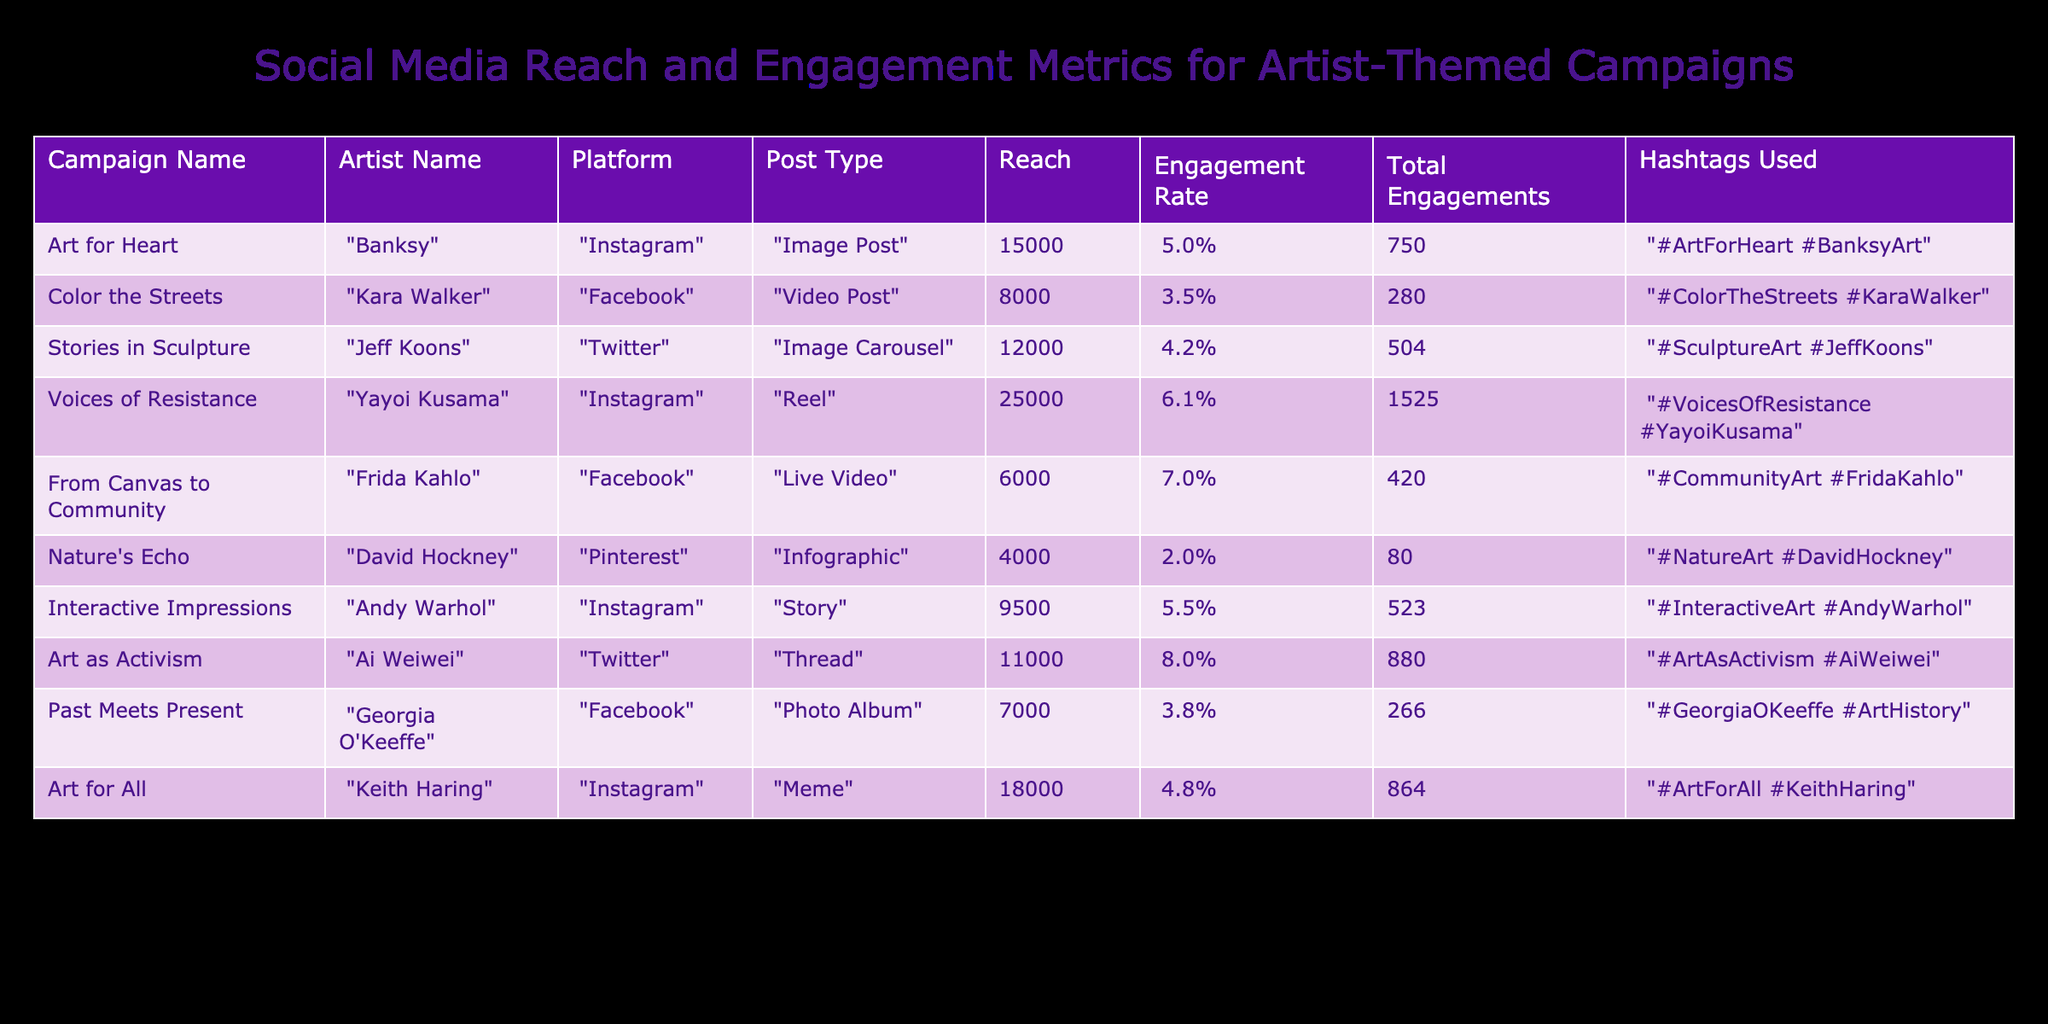What is the total reach for the campaign "Voices of Resistance"? The table shows that the reach for "Voices of Resistance" is listed in its respective row. By directly referring to the 'Reach' column for this campaign, we can see that it is 25000.
Answer: 25000 Which artist's campaign had the highest engagement rate? To find the highest engagement rate, we can look at the 'Engagement Rate' column. Comparing the values, we see that "Art as Activism" by Ai Weiwei has the highest engagement rate of 8.0%.
Answer: Ai Weiwei What is the average total engagements across all campaigns? We first need to sum the total engagements of all campaigns. The values are 750, 280, 504, 1525, 420, 80, 523, 880, 266, and 864. Adding these gives a total of 4878. There are 10 campaigns, so the average is 4878 divided by 10, which equals 487.8.
Answer: 487.8 Did all campaigns use hashtags? We can check all the rows in the 'Hashtags Used' column to see if there are any missing entries. Each campaign listed has associated hashtags, meaning all campaigns used hashtags.
Answer: Yes How much more reach did "Art for Heart" have compared to "Nature's Echo"? To find the difference in reach, we look at "Art for Heart," which has a reach of 15000, and "Nature's Echo," which has a reach of 4000. Subtracting these gives 15000 - 4000 = 11000 as the additional reach of "Art for Heart."
Answer: 11000 Which platform had the highest total engagement from all campaigns combined? To determine the platform with the highest total engagements, we sum the total engagements for each platform: Instagram (750 + 1525 + 523 + 864 = 2862), Facebook (280 + 420 + 266 = 966), Twitter (504 + 880 = 1384), and Pinterest (80). The highest is Instagram with a total of 2862 engagements.
Answer: Instagram What percentage of total engagements came from "Interactive Impressions"? First, find the total engagements from "Interactive Impressions," which is 523. Then, compare it with the total engagements of all campaigns, which is 4878. The percentage is calculated as (523 / 4878) * 100 = approximately 10.7%.
Answer: 10.7% Is it true that all campaigns conducted through Facebook had lower engagement rates than those conducted on Instagram? We first check the 'Engagement Rate' for the Facebook campaigns: "Color the Streets" (3.5%), "From Canvas to Community" (7.0%), and "Past Meets Present" (3.8%). Comparing these with Instagram campaigns: "Art for Heart" (5.0%), "Voices of Resistance" (6.1%), and "Art for All" (4.8%), we note that "From Canvas to Community" has a higher engagement rate than "Art for Heart" and "Art for All." Therefore, the statement is false.
Answer: No What is the total engagement for artists whose campaigns had a reach over 10000? We check the campaigns: "Voices of Resistance" (1525), "Art as Activism" (880), and "Art for All" (864), which all exceeded 10000 in reach. Adding these engagements gives us 1525 + 880 + 864 = 3269 total engagements from these campaigns.
Answer: 3269 